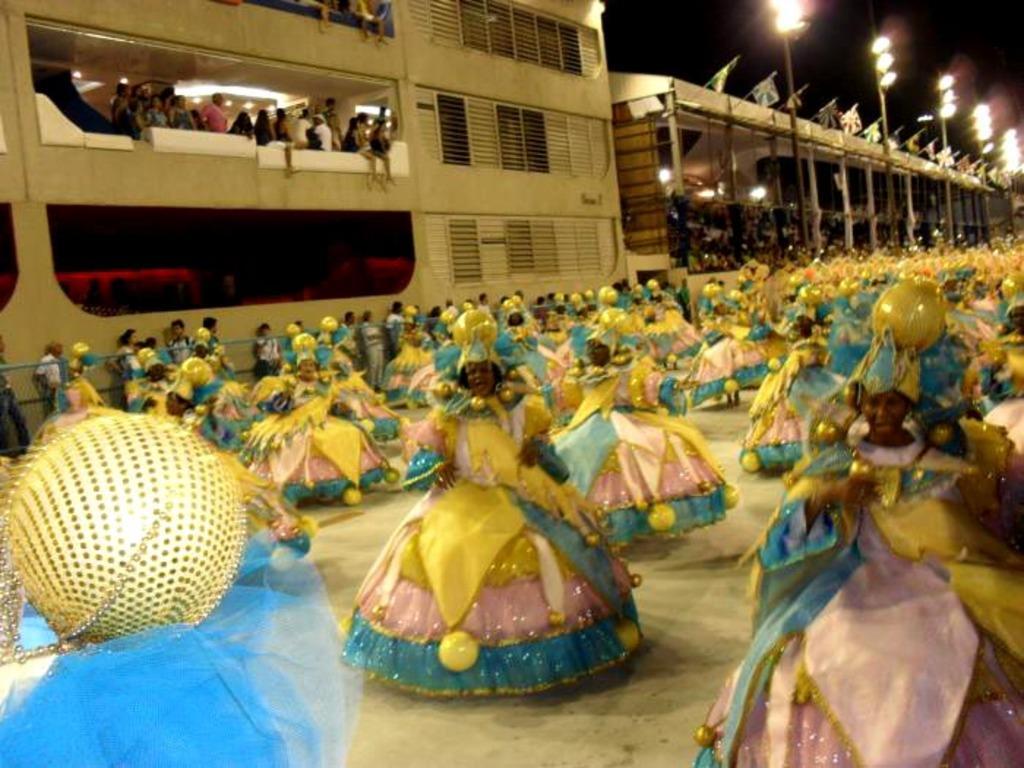Can you describe this image briefly? In this image there are group of people who are wearing some costumes, and it seems that they are dancing. At the bottom there is floor, on the left side there is a wall and net. In the background there are some poles and buildings, at the top there are some lights. 